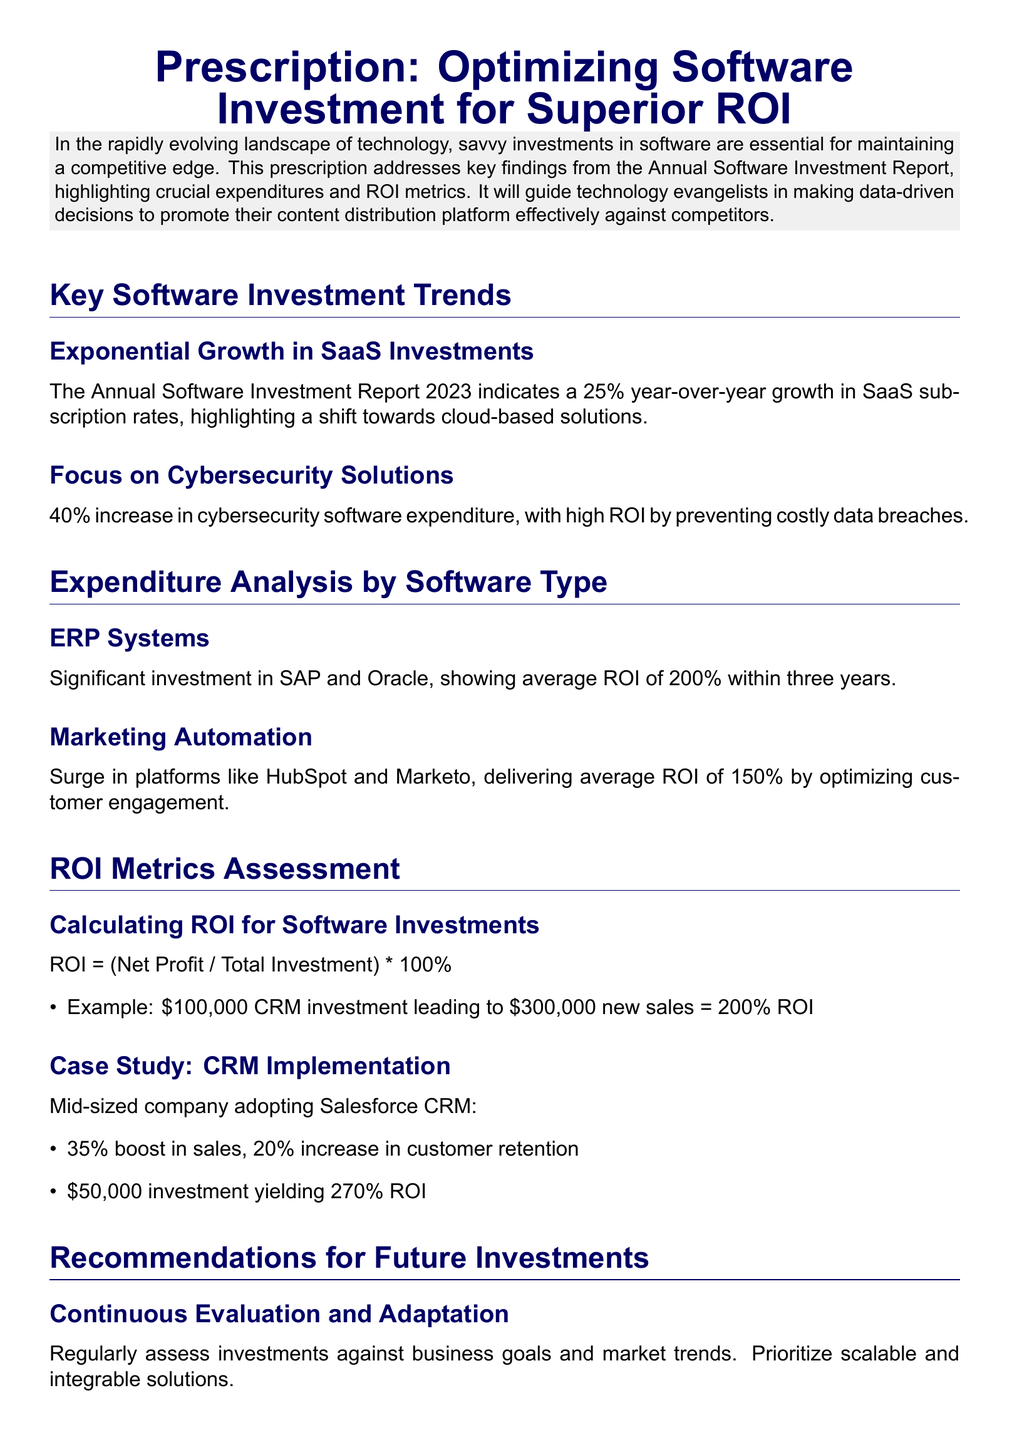What is the title of the document? The title of the document is presented prominently at the top, summarizing its focus.
Answer: Prescription: Optimizing Software Investment for Superior ROI What is the year-over-year growth percentage for SaaS investments? This percentage is explicitly stated in the report under key investment trends.
Answer: 25% What is the average ROI for ERP systems within three years? The document specifies the ROI metric for ERP systems, providing a clear financial indicator.
Answer: 200% What was the increase percentage in cybersecurity software expenditure? This figure is mentioned under key software investment trends, reflecting the focus on cybersecurity.
Answer: 40% What is the ROI for the CRM investment example provided in the document? The document provides a specific example to illustrate how to calculate ROI based on investment and sales increase.
Answer: 200% Which marketing automation platforms are highlighted? The document mentions specific platforms that have seen increased investment, pinpointing their relevance.
Answer: HubSpot and Marketo What is recommended to prioritize in future investments? A key recommendation is given in the document, focusing on the type of solutions that should be emphasized.
Answer: Customer-Centric Solutions What was the ROI yielded by the Salesforce CRM implementation? The document provides a specific case study with its corresponding ROI calculation, serving as an example.
Answer: 270% What is the investment amount for the case study on CRM implementation? The document specifies this amount in the context of the case study about a mid-sized company.
Answer: $50,000 